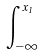Convert formula to latex. <formula><loc_0><loc_0><loc_500><loc_500>\int _ { - \infty } ^ { x _ { 1 } }</formula> 